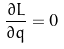<formula> <loc_0><loc_0><loc_500><loc_500>\frac { \partial L } { \partial q } = 0</formula> 